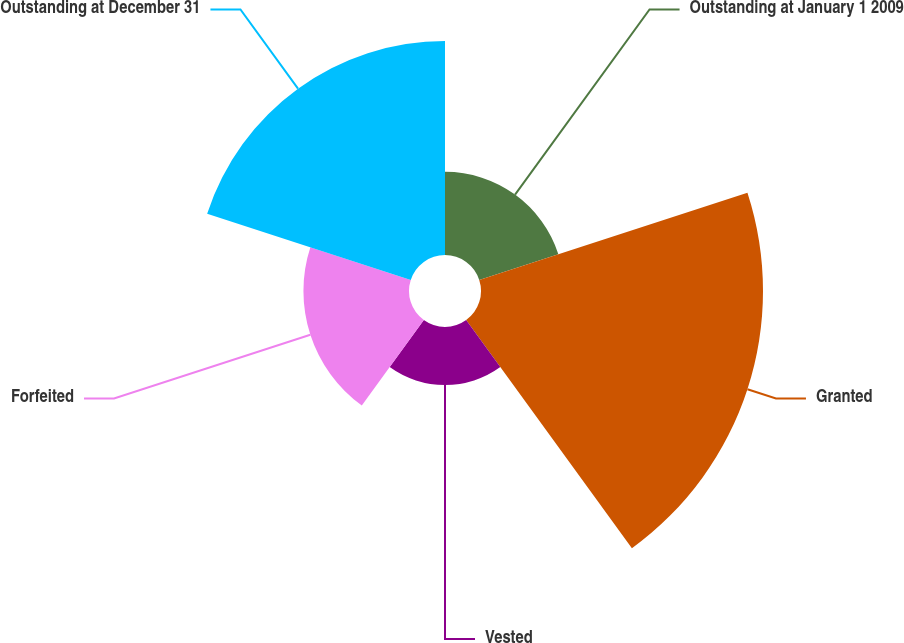<chart> <loc_0><loc_0><loc_500><loc_500><pie_chart><fcel>Outstanding at January 1 2009<fcel>Granted<fcel>Vested<fcel>Forfeited<fcel>Outstanding at December 31<nl><fcel>11.2%<fcel>37.96%<fcel>7.82%<fcel>14.21%<fcel>28.82%<nl></chart> 